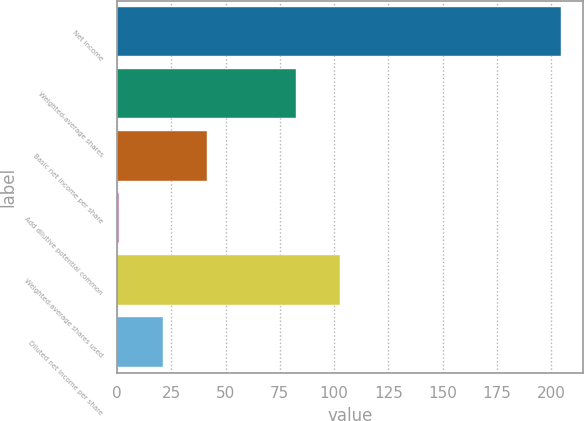Convert chart. <chart><loc_0><loc_0><loc_500><loc_500><bar_chart><fcel>Net income<fcel>Weighted-average shares<fcel>Basic net income per share<fcel>Add dilutive potential common<fcel>Weighted-average shares used<fcel>Diluted net income per share<nl><fcel>204.3<fcel>82.32<fcel>41.66<fcel>1<fcel>102.65<fcel>21.33<nl></chart> 